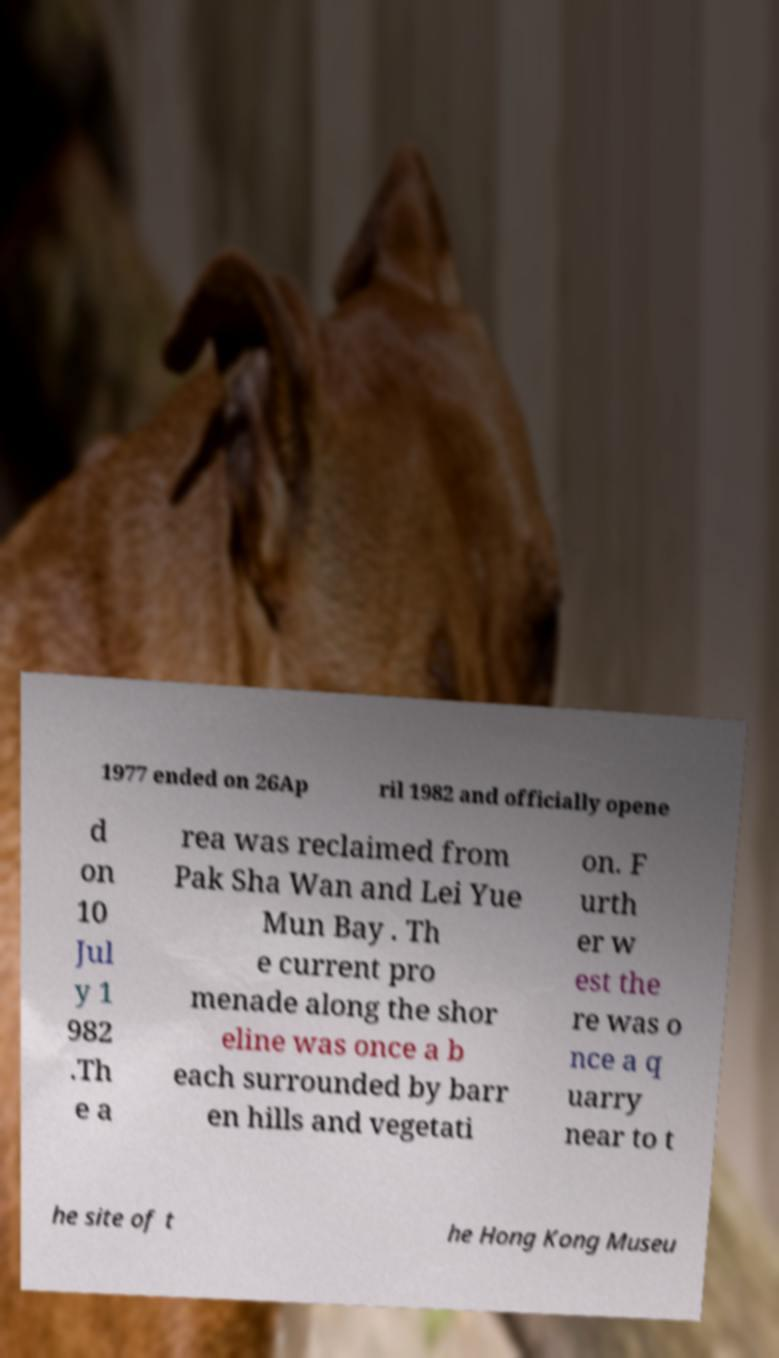There's text embedded in this image that I need extracted. Can you transcribe it verbatim? 1977 ended on 26Ap ril 1982 and officially opene d on 10 Jul y 1 982 .Th e a rea was reclaimed from Pak Sha Wan and Lei Yue Mun Bay . Th e current pro menade along the shor eline was once a b each surrounded by barr en hills and vegetati on. F urth er w est the re was o nce a q uarry near to t he site of t he Hong Kong Museu 